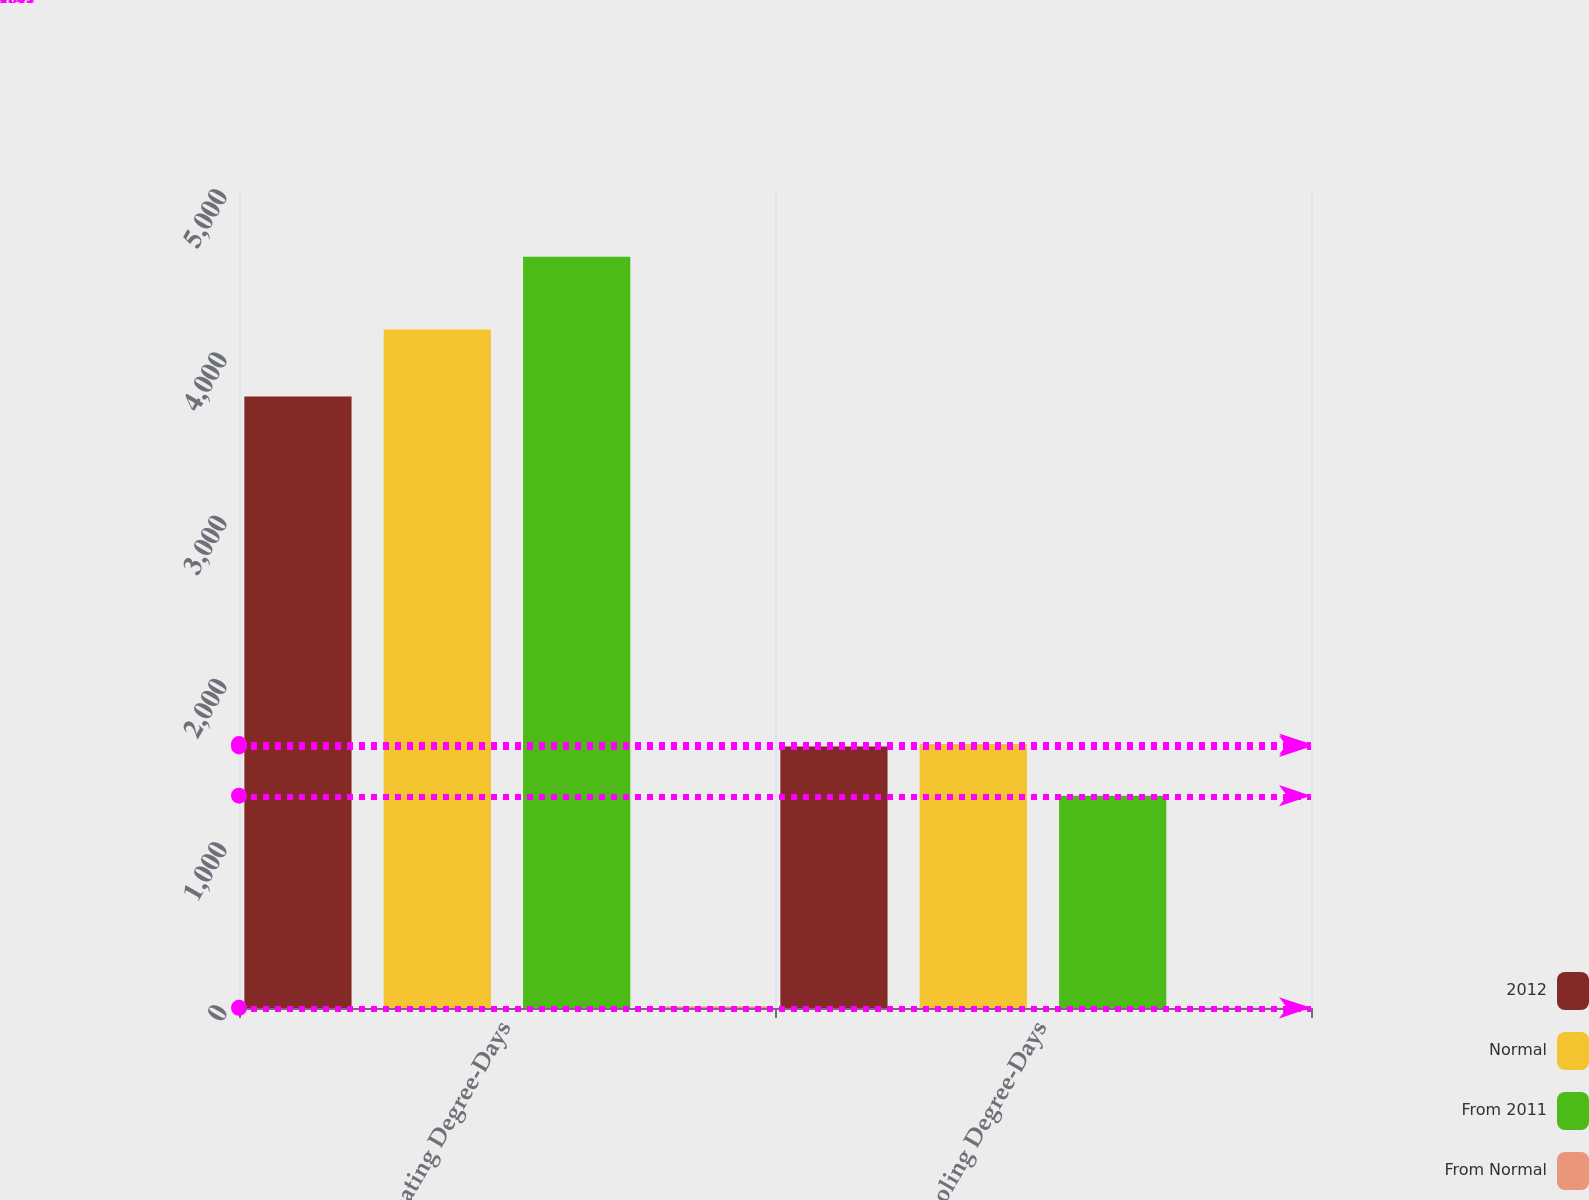Convert chart. <chart><loc_0><loc_0><loc_500><loc_500><stacked_bar_chart><ecel><fcel>Heating Degree-Days<fcel>Cooling Degree-Days<nl><fcel>2012<fcel>3747<fcel>1603<nl><fcel>Normal<fcel>4157<fcel>1617<nl><fcel>From 2011<fcel>4603<fcel>1301<nl><fcel>From Normal<fcel>9.9<fcel>0.9<nl></chart> 